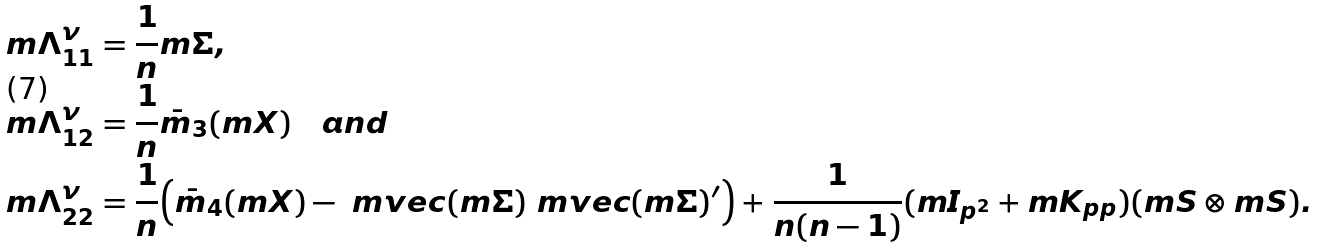<formula> <loc_0><loc_0><loc_500><loc_500>& m { \Lambda } _ { 1 1 } ^ { \nu } = \frac { 1 } { n } m { \Sigma } , \\ & m { \Lambda } _ { 1 2 } ^ { \nu } = \frac { 1 } { n } \bar { m } _ { 3 } ( m { X } ) \quad a n d \\ & m { \Lambda } _ { 2 2 } ^ { \nu } = \frac { 1 } { n } \Big { ( } \bar { m } _ { 4 } ( m { X } ) - \ m v e c ( m { \Sigma } ) \ m v e c ( m { \Sigma } ) ^ { \prime } \Big { ) } + \frac { 1 } { n ( n - 1 ) } ( m { I } _ { p ^ { 2 } } + m { K } _ { p p } ) ( m { S } \otimes m { S } ) .</formula> 